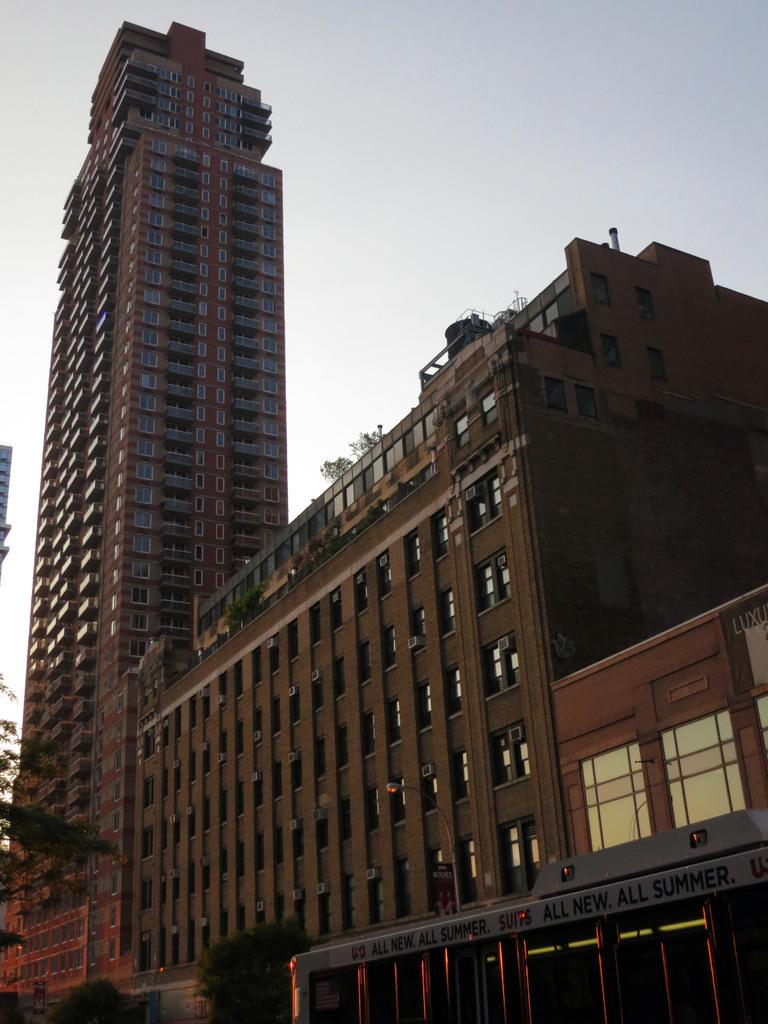What structures can be seen in the right corner of the image? There are buildings in the right corner of the image. What type of vegetation is present in the left corner of the image? There are trees in the left corner of the image. What type of jam is being served at the party in the image? There is no party or jam present in the image; it only features buildings and trees. 